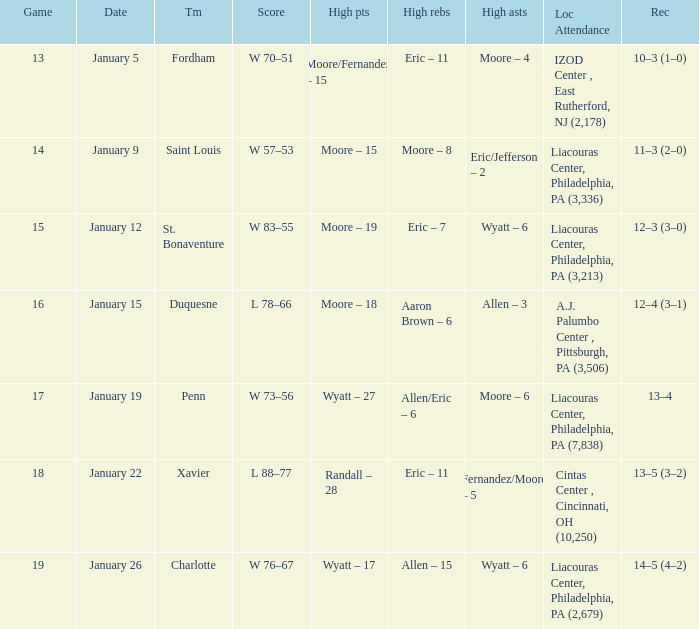Give me the full table as a dictionary. {'header': ['Game', 'Date', 'Tm', 'Score', 'High pts', 'High rebs', 'High asts', 'Loc Attendance', 'Rec'], 'rows': [['13', 'January 5', 'Fordham', 'W 70–51', 'Moore/Fernandez – 15', 'Eric – 11', 'Moore – 4', 'IZOD Center , East Rutherford, NJ (2,178)', '10–3 (1–0)'], ['14', 'January 9', 'Saint Louis', 'W 57–53', 'Moore – 15', 'Moore – 8', 'Eric/Jefferson – 2', 'Liacouras Center, Philadelphia, PA (3,336)', '11–3 (2–0)'], ['15', 'January 12', 'St. Bonaventure', 'W 83–55', 'Moore – 19', 'Eric – 7', 'Wyatt – 6', 'Liacouras Center, Philadelphia, PA (3,213)', '12–3 (3–0)'], ['16', 'January 15', 'Duquesne', 'L 78–66', 'Moore – 18', 'Aaron Brown – 6', 'Allen – 3', 'A.J. Palumbo Center , Pittsburgh, PA (3,506)', '12–4 (3–1)'], ['17', 'January 19', 'Penn', 'W 73–56', 'Wyatt – 27', 'Allen/Eric – 6', 'Moore – 6', 'Liacouras Center, Philadelphia, PA (7,838)', '13–4'], ['18', 'January 22', 'Xavier', 'L 88–77', 'Randall – 28', 'Eric – 11', 'Fernandez/Moore – 5', 'Cintas Center , Cincinnati, OH (10,250)', '13–5 (3–2)'], ['19', 'January 26', 'Charlotte', 'W 76–67', 'Wyatt – 17', 'Allen – 15', 'Wyatt – 6', 'Liacouras Center, Philadelphia, PA (2,679)', '14–5 (4–2)']]} On january 5, who recorded the highest number of assists and what was the count? Moore – 4. 